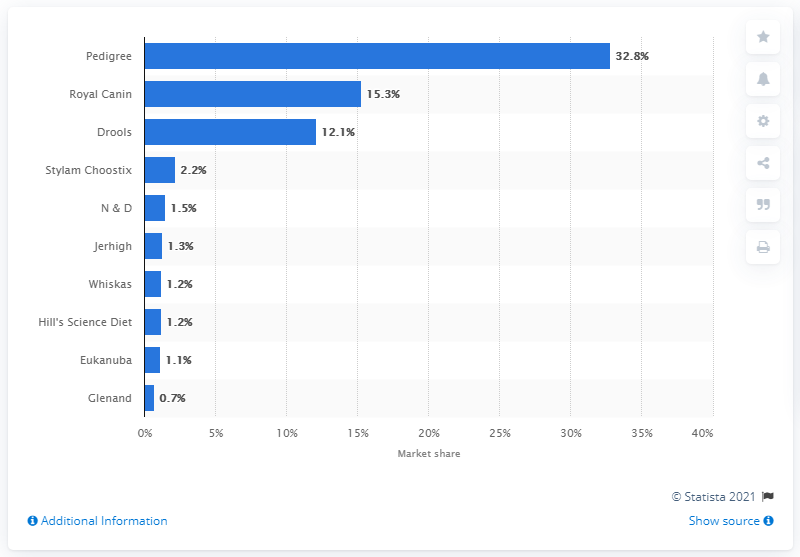Mention a couple of crucial points in this snapshot. It is reported that in 2017, Pedigree was the most popular pet food brand in India. In 2017, Pedigree's market share in India was 32.8%. 